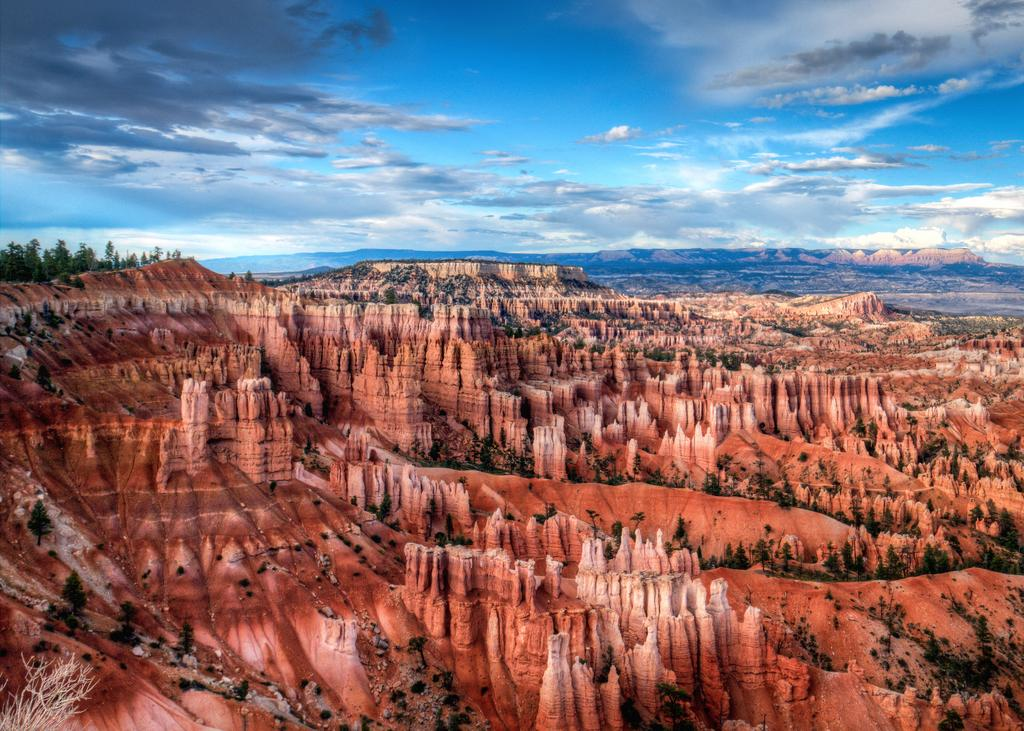What is the main subject in the center of the image? There are rocks in the center of the image. What type of vegetation can be seen on the left side of the image? There are trees on the left side of the image. What is the condition of the sky in the image? The sky is cloudy in the image. What type of verse can be seen written on the wrist of the person in the image? There is no person present in the image, and therefore no verse can be seen written on a wrist. 